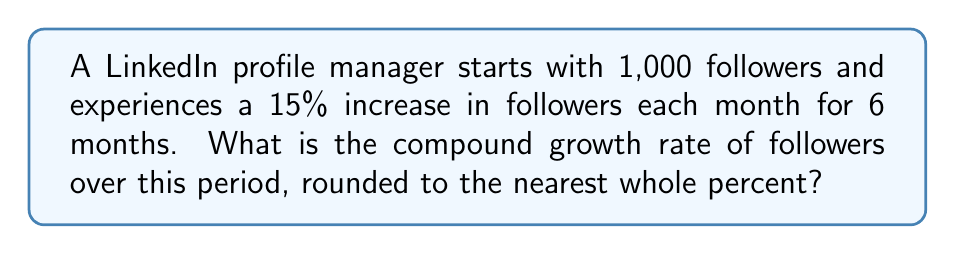Help me with this question. To solve this problem, we'll follow these steps:

1. Calculate the final number of followers after 6 months.
2. Use the compound growth rate formula to find the rate.
3. Convert the rate to a percentage and round to the nearest whole percent.

Step 1: Calculate the final number of followers
Initial followers: 1,000
Monthly growth rate: 15% = 0.15
Number of months: 6

Final followers = Initial followers × (1 + growth rate)^(number of months)
$$ \text{Final followers} = 1000 \times (1 + 0.15)^6 $$
$$ = 1000 \times (1.15)^6 $$
$$ = 1000 \times 2.3131 $$
$$ = 2,313.1 $$

Step 2: Use the compound growth rate formula
The compound growth rate (r) is given by:
$$ (1 + r)^n = \frac{\text{Final Value}}{\text{Initial Value}} $$

Where n is the number of periods (6 months in this case).

Substituting our values:
$$ (1 + r)^6 = \frac{2313.1}{1000} $$
$$ (1 + r)^6 = 2.3131 $$

Taking the 6th root of both sides:
$$ 1 + r = \sqrt[6]{2.3131} $$
$$ 1 + r = 1.1499 $$
$$ r = 1.1499 - 1 = 0.1499 $$

Step 3: Convert to percentage and round
$$ 0.1499 \times 100 = 14.99\% $$

Rounding to the nearest whole percent: 15%
Answer: 15% 